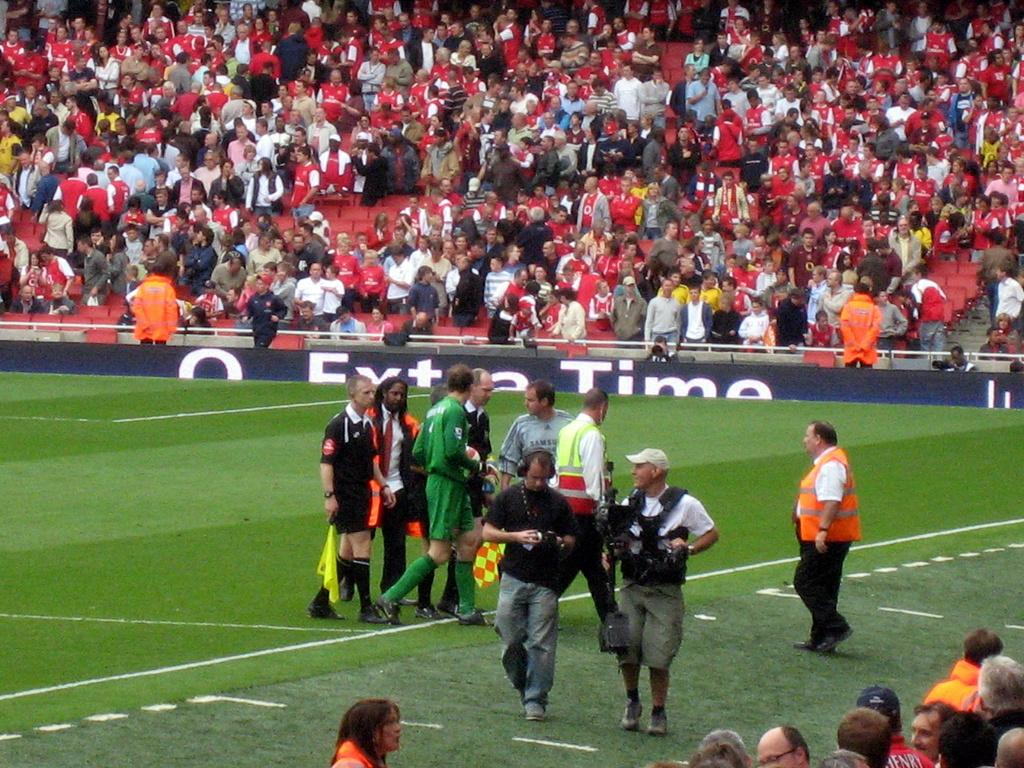<image>
Write a terse but informative summary of the picture. Group of soccer players on the field in front of a sign that says Extra Time. 